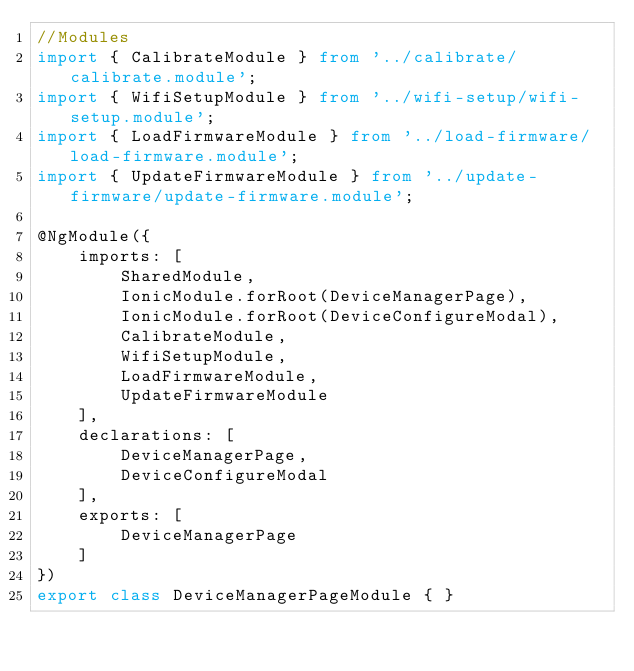<code> <loc_0><loc_0><loc_500><loc_500><_TypeScript_>//Modules
import { CalibrateModule } from '../calibrate/calibrate.module';
import { WifiSetupModule } from '../wifi-setup/wifi-setup.module';
import { LoadFirmwareModule } from '../load-firmware/load-firmware.module';
import { UpdateFirmwareModule } from '../update-firmware/update-firmware.module';

@NgModule({
    imports: [
        SharedModule,
        IonicModule.forRoot(DeviceManagerPage),
        IonicModule.forRoot(DeviceConfigureModal),
        CalibrateModule,
        WifiSetupModule,
        LoadFirmwareModule,
        UpdateFirmwareModule
    ],
    declarations: [
        DeviceManagerPage,
        DeviceConfigureModal
    ],
    exports: [
        DeviceManagerPage
    ]
})
export class DeviceManagerPageModule { }
</code> 